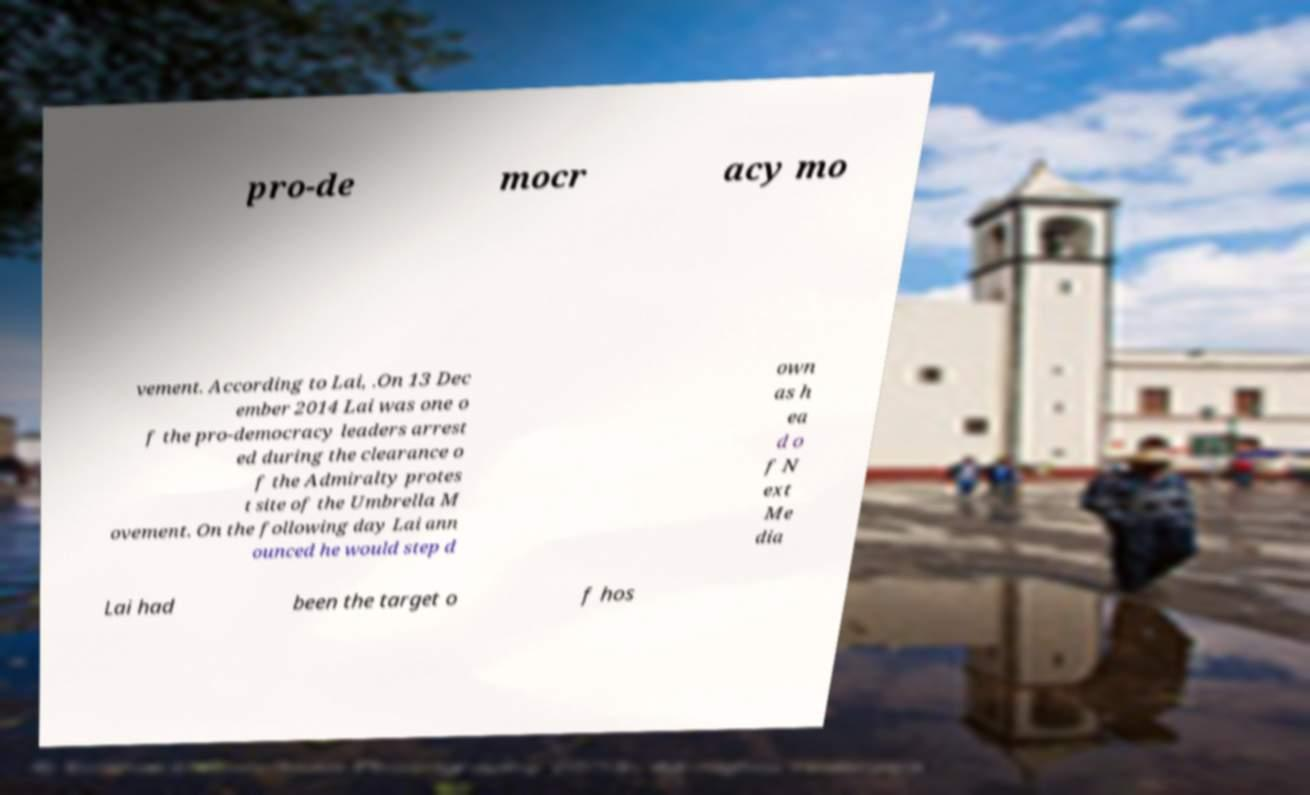Can you accurately transcribe the text from the provided image for me? pro-de mocr acy mo vement. According to Lai, .On 13 Dec ember 2014 Lai was one o f the pro-democracy leaders arrest ed during the clearance o f the Admiralty protes t site of the Umbrella M ovement. On the following day Lai ann ounced he would step d own as h ea d o f N ext Me dia Lai had been the target o f hos 